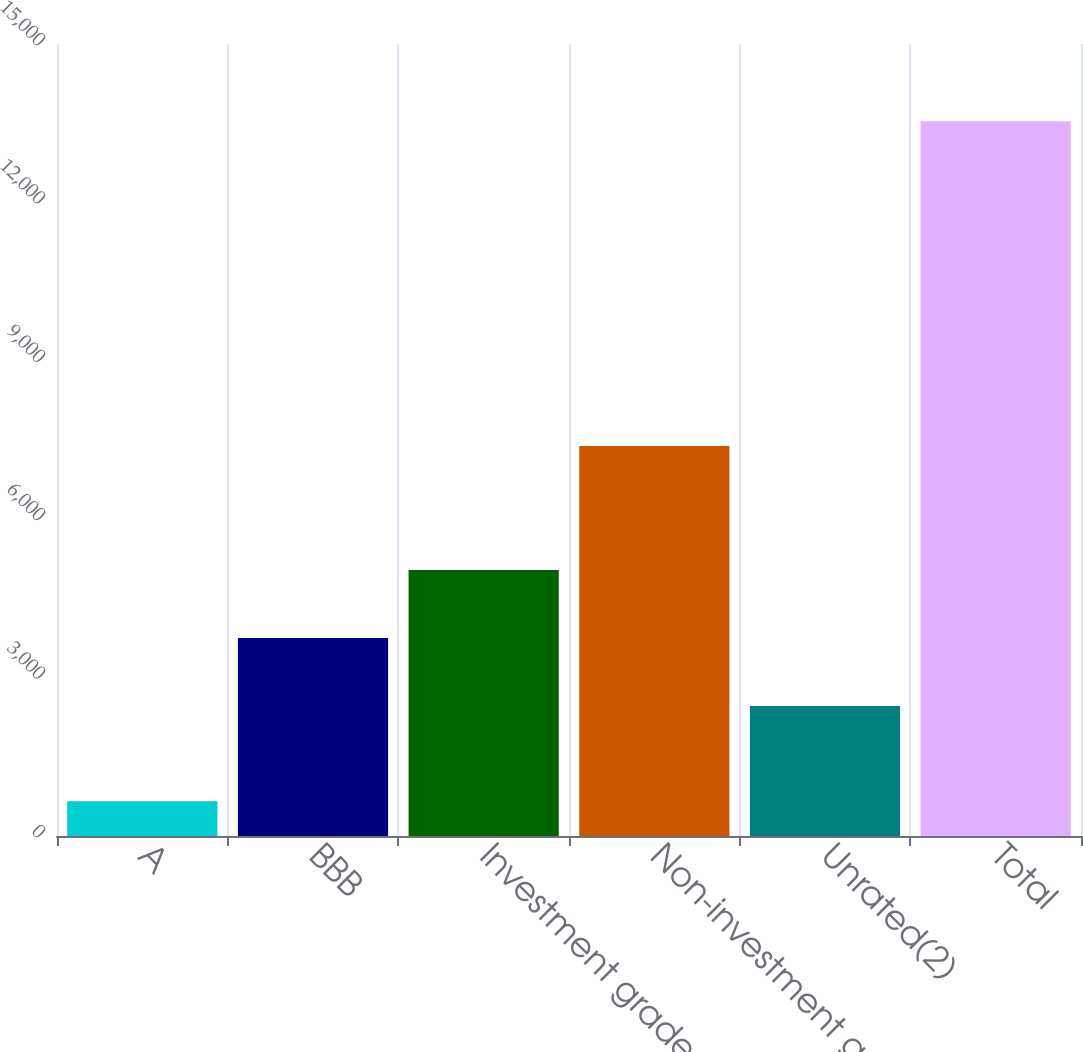Convert chart to OTSL. <chart><loc_0><loc_0><loc_500><loc_500><bar_chart><fcel>A<fcel>BBB<fcel>Investment grade<fcel>Non-investment grade<fcel>Unrated(2)<fcel>Total<nl><fcel>657<fcel>3748.1<fcel>5036.2<fcel>7386<fcel>2460<fcel>13538<nl></chart> 